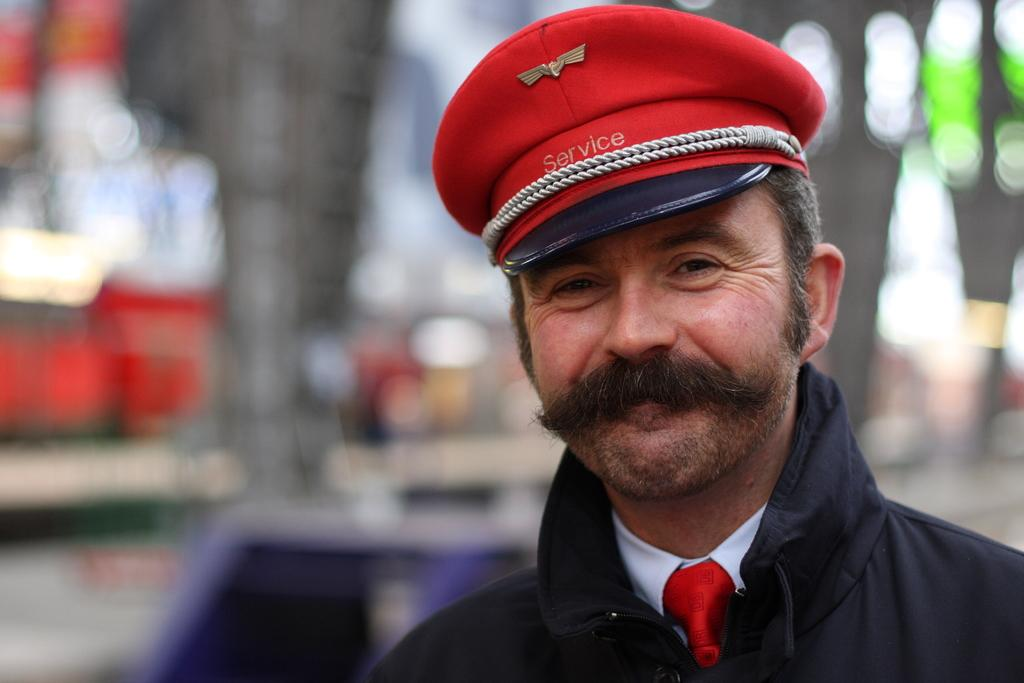What is the main subject of the image? There is a person in the image. What is the person doing in the image? The person is standing and smiling. Can you describe the background of the image? The background of the image is blurry. What type of sign can be seen in the person's hand in the image? There is no sign visible in the person's hand in the image. Is there a kite flying in the background of the image? There is no kite present in the image. 